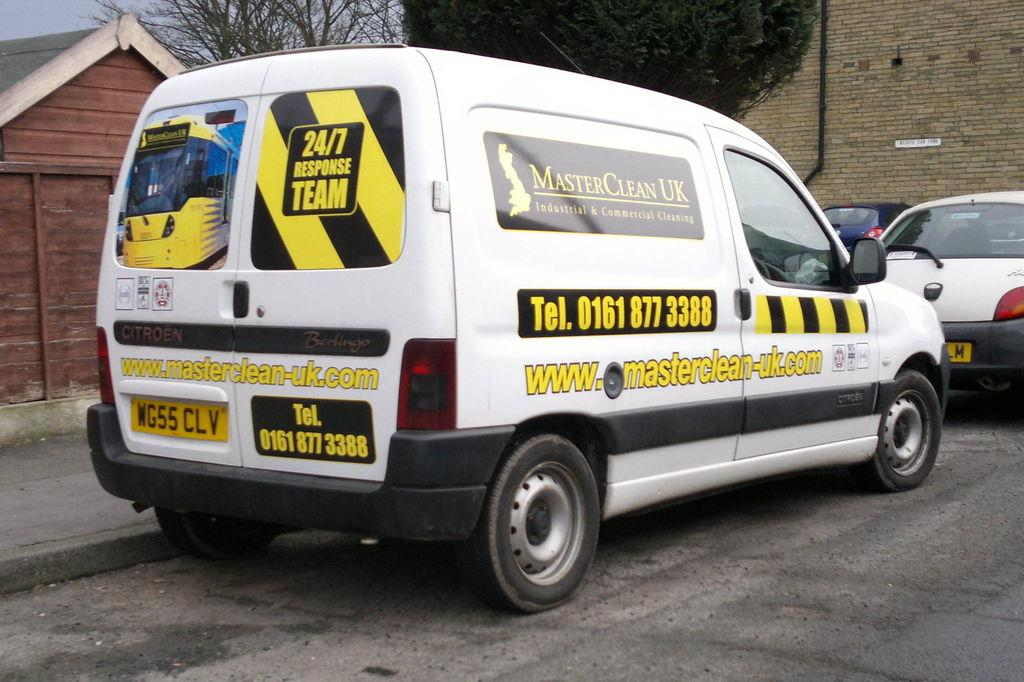<image>
Relay a brief, clear account of the picture shown. A white work company van says Master Clean UK on the side. 